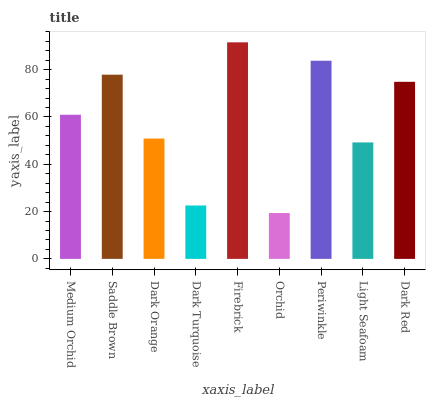Is Orchid the minimum?
Answer yes or no. Yes. Is Firebrick the maximum?
Answer yes or no. Yes. Is Saddle Brown the minimum?
Answer yes or no. No. Is Saddle Brown the maximum?
Answer yes or no. No. Is Saddle Brown greater than Medium Orchid?
Answer yes or no. Yes. Is Medium Orchid less than Saddle Brown?
Answer yes or no. Yes. Is Medium Orchid greater than Saddle Brown?
Answer yes or no. No. Is Saddle Brown less than Medium Orchid?
Answer yes or no. No. Is Medium Orchid the high median?
Answer yes or no. Yes. Is Medium Orchid the low median?
Answer yes or no. Yes. Is Dark Red the high median?
Answer yes or no. No. Is Orchid the low median?
Answer yes or no. No. 